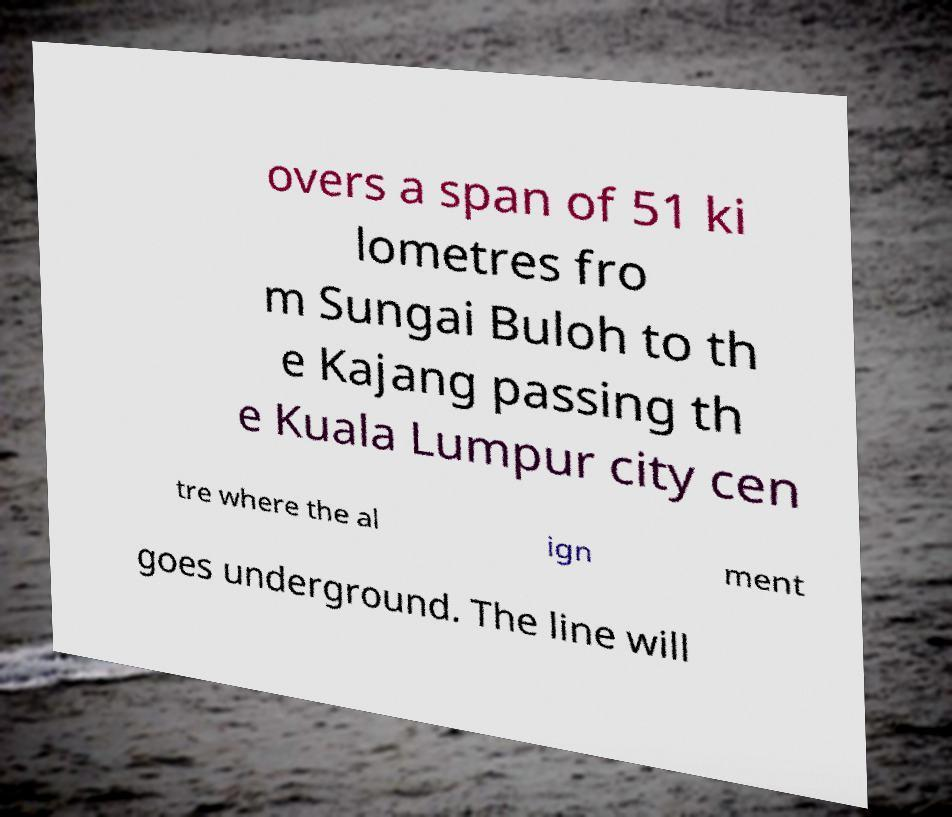Could you assist in decoding the text presented in this image and type it out clearly? overs a span of 51 ki lometres fro m Sungai Buloh to th e Kajang passing th e Kuala Lumpur city cen tre where the al ign ment goes underground. The line will 